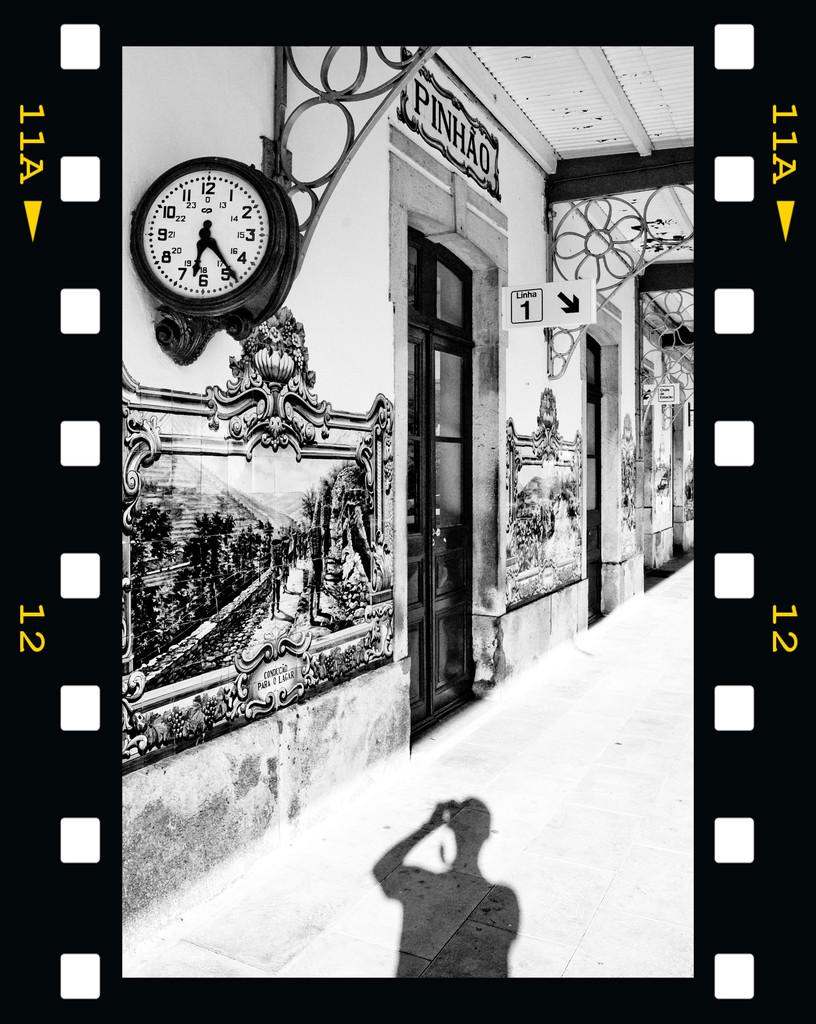What number and letter combo is on top on both sides?
Keep it short and to the point. 11a. 